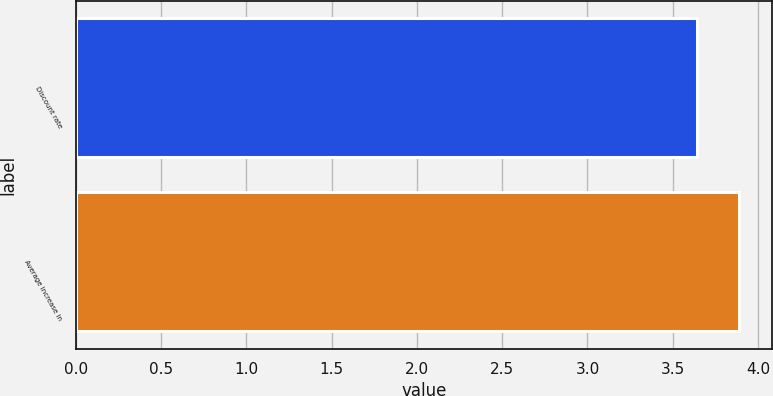Convert chart. <chart><loc_0><loc_0><loc_500><loc_500><bar_chart><fcel>Discount rate<fcel>Average increase in<nl><fcel>3.64<fcel>3.89<nl></chart> 